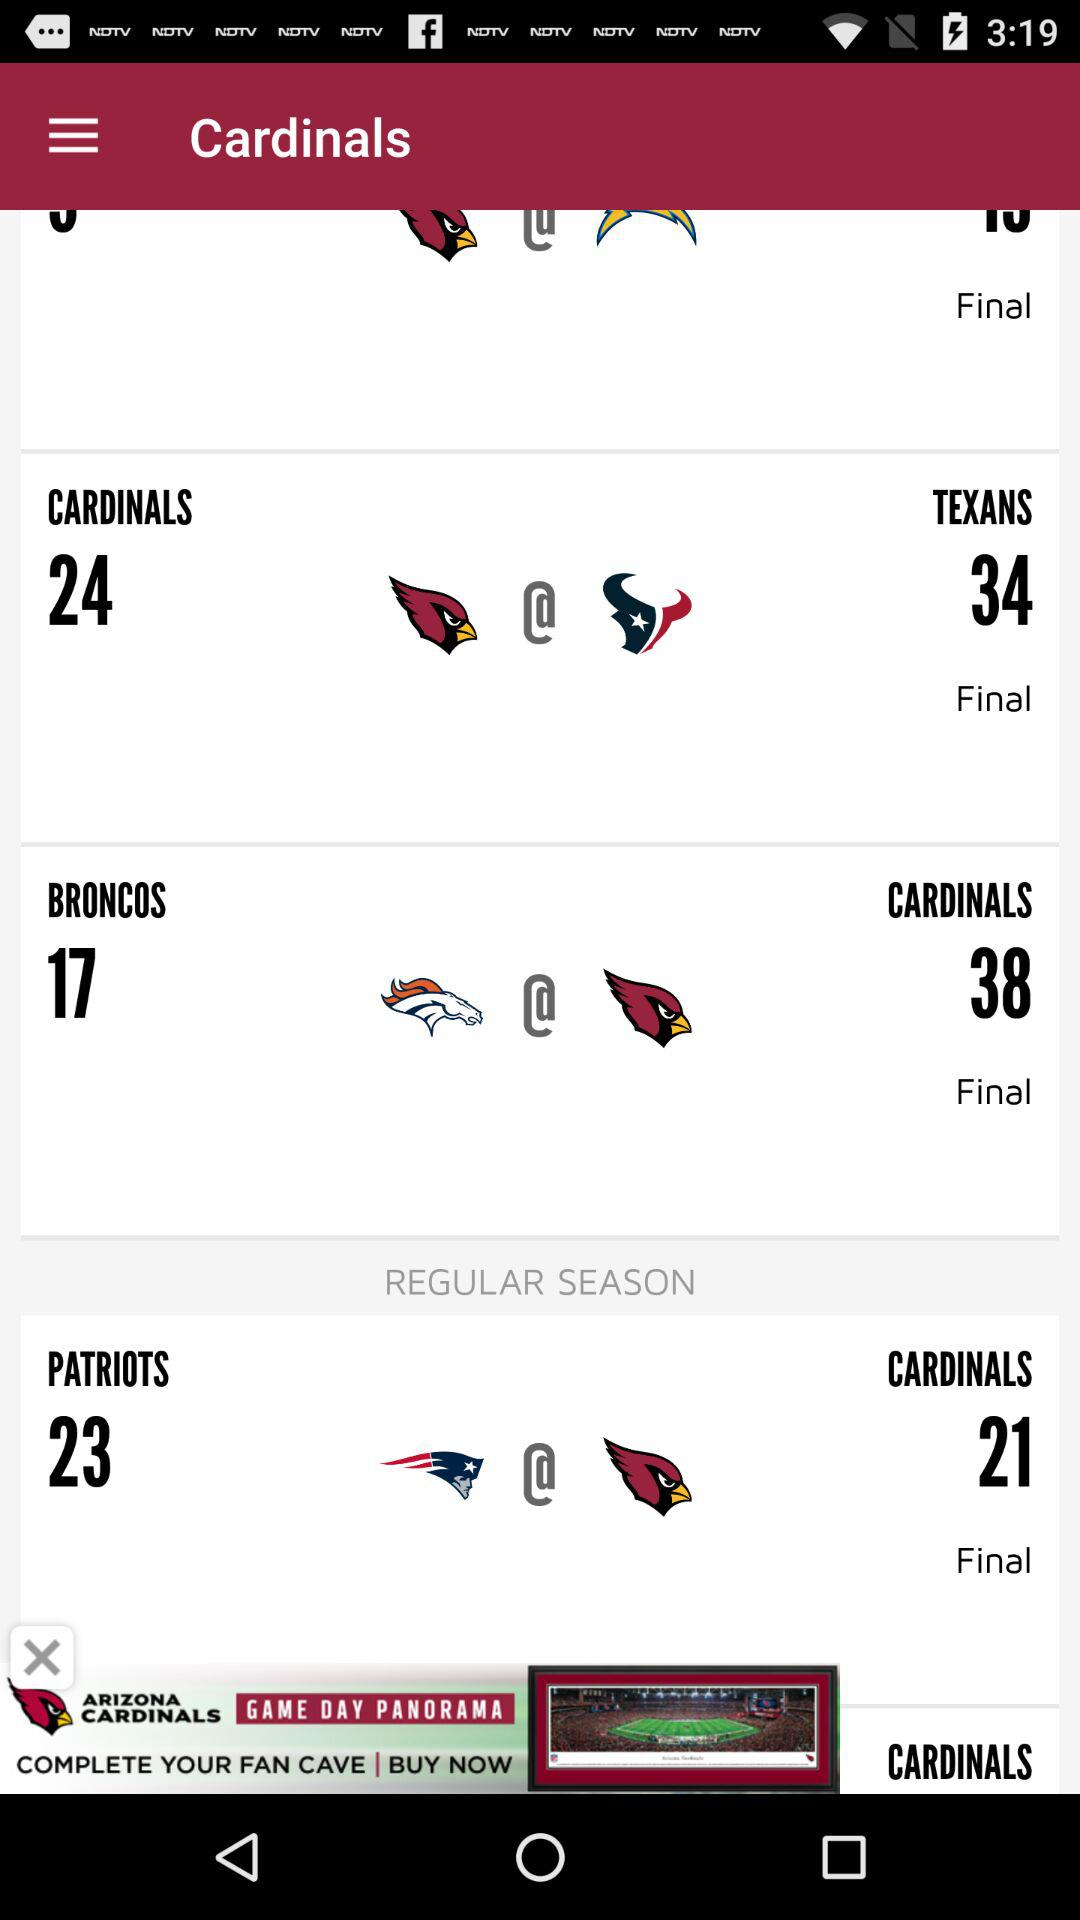How many more points did Arizona Cardinals score in their game against the Denver Broncos than the Patriots?
Answer the question using a single word or phrase. 17 